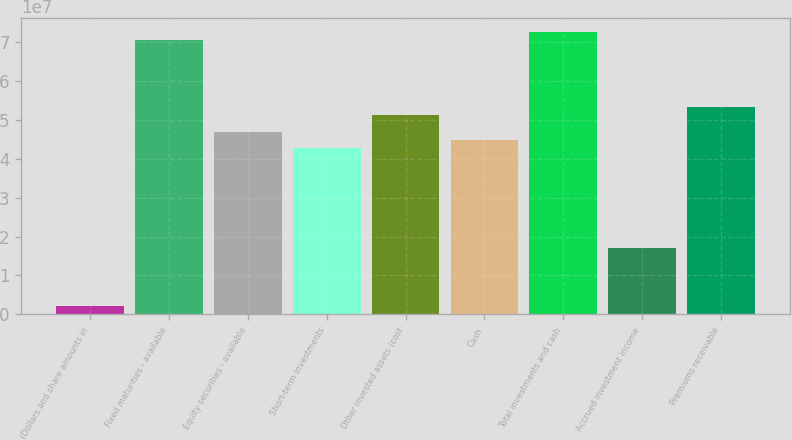<chart> <loc_0><loc_0><loc_500><loc_500><bar_chart><fcel>(Dollars and share amounts in<fcel>Fixed maturities - available<fcel>Equity securities - available<fcel>Short-term investments<fcel>Other invested assets (cost<fcel>Cash<fcel>Total investments and cash<fcel>Accrued investment income<fcel>Premiums receivable<nl><fcel>2.13277e+06<fcel>7.03594e+07<fcel>4.69065e+07<fcel>4.26423e+07<fcel>5.11706e+07<fcel>4.47744e+07<fcel>7.24915e+07<fcel>1.70573e+07<fcel>5.33027e+07<nl></chart> 